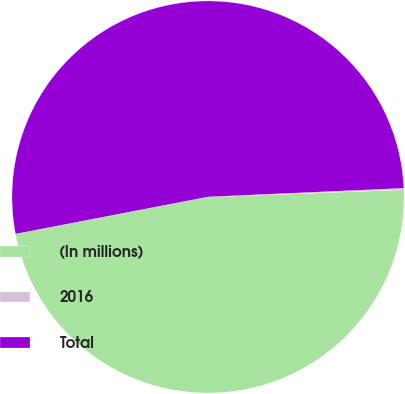Convert chart to OTSL. <chart><loc_0><loc_0><loc_500><loc_500><pie_chart><fcel>(In millions)<fcel>2016<fcel>Total<nl><fcel>47.56%<fcel>0.12%<fcel>52.32%<nl></chart> 